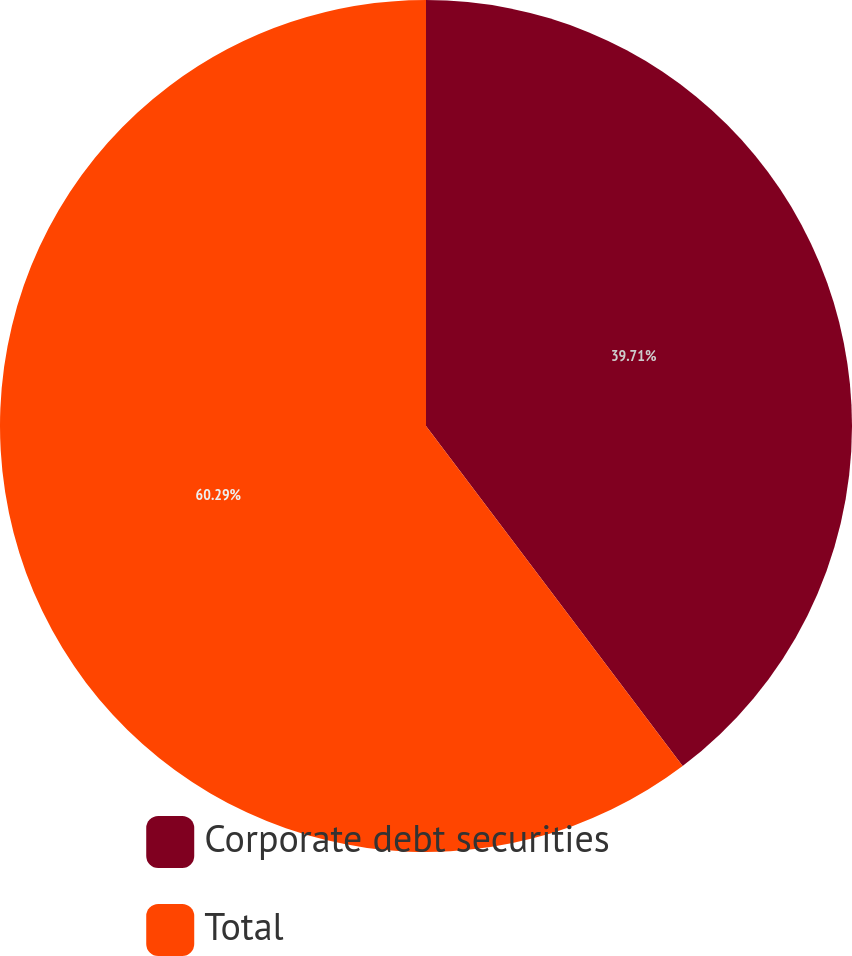Convert chart to OTSL. <chart><loc_0><loc_0><loc_500><loc_500><pie_chart><fcel>Corporate debt securities<fcel>Total<nl><fcel>39.71%<fcel>60.29%<nl></chart> 